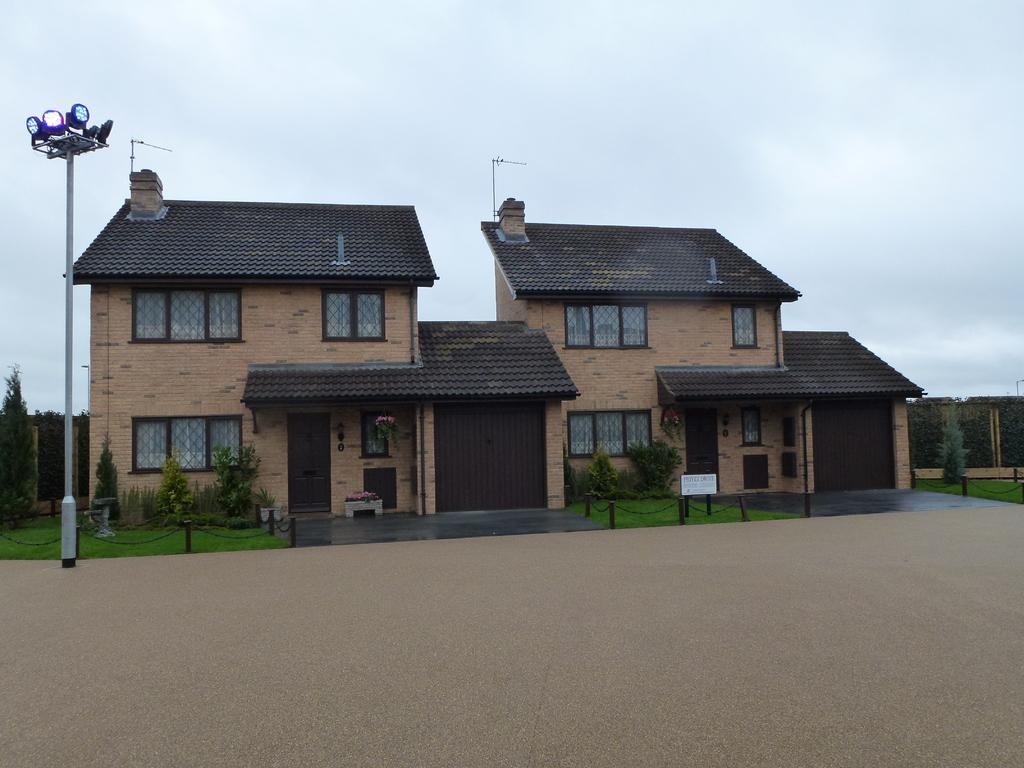What type of structure is visible in the image? There is a house in the image. What is the landscape like in front of the house? There is an open land in front of the house. What object can be seen near the house? There is a pole in the image. What is the purpose of the pole? Different lights are fitted to the pole, suggesting it might be a street light or a decorative light pole. What type of cake is being served at the reading event in the image? There is no reading event or cake present in the image. The image features a house, open land, and a pole with lights. 